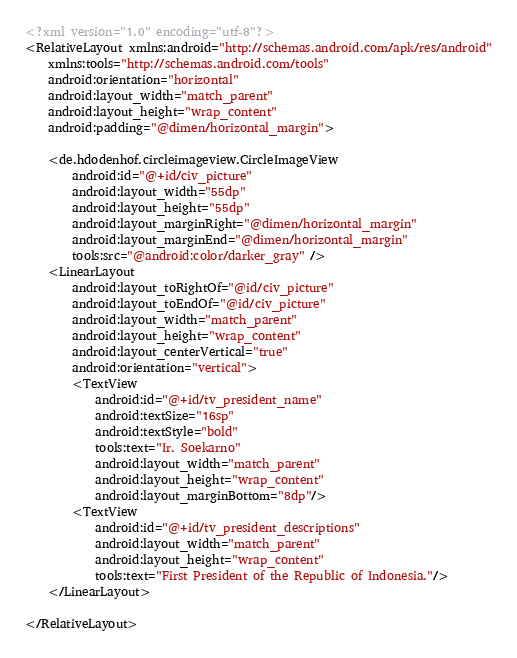Convert code to text. <code><loc_0><loc_0><loc_500><loc_500><_XML_><?xml version="1.0" encoding="utf-8"?>
<RelativeLayout xmlns:android="http://schemas.android.com/apk/res/android"
    xmlns:tools="http://schemas.android.com/tools"
    android:orientation="horizontal"
    android:layout_width="match_parent"
    android:layout_height="wrap_content"
    android:padding="@dimen/horizontal_margin">

    <de.hdodenhof.circleimageview.CircleImageView
        android:id="@+id/civ_picture"
        android:layout_width="55dp"
        android:layout_height="55dp"
        android:layout_marginRight="@dimen/horizontal_margin"
        android:layout_marginEnd="@dimen/horizontal_margin"
        tools:src="@android:color/darker_gray" />
    <LinearLayout
        android:layout_toRightOf="@id/civ_picture"
        android:layout_toEndOf="@id/civ_picture"
        android:layout_width="match_parent"
        android:layout_height="wrap_content"
        android:layout_centerVertical="true"
        android:orientation="vertical">
        <TextView
            android:id="@+id/tv_president_name"
            android:textSize="16sp"
            android:textStyle="bold"
            tools:text="Ir. Soekarno"
            android:layout_width="match_parent"
            android:layout_height="wrap_content"
            android:layout_marginBottom="8dp"/>
        <TextView
            android:id="@+id/tv_president_descriptions"
            android:layout_width="match_parent"
            android:layout_height="wrap_content"
            tools:text="First President of the Republic of Indonesia."/>
    </LinearLayout>

</RelativeLayout></code> 